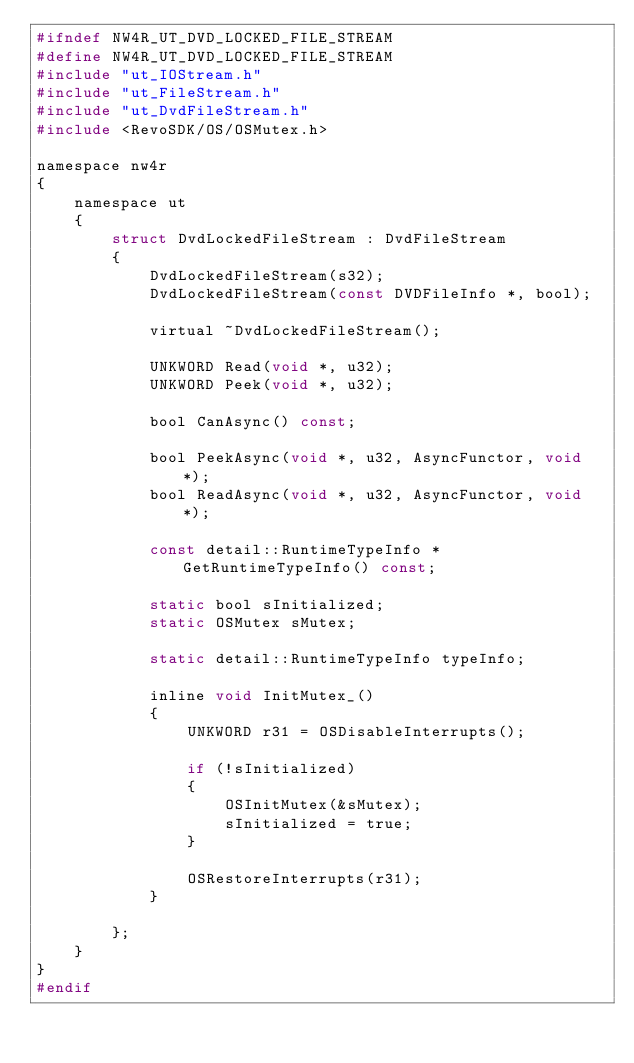<code> <loc_0><loc_0><loc_500><loc_500><_C_>#ifndef NW4R_UT_DVD_LOCKED_FILE_STREAM
#define NW4R_UT_DVD_LOCKED_FILE_STREAM
#include "ut_IOStream.h"
#include "ut_FileStream.h"
#include "ut_DvdFileStream.h"
#include <RevoSDK/OS/OSMutex.h>

namespace nw4r
{
	namespace ut
	{
		struct DvdLockedFileStream : DvdFileStream
		{
			DvdLockedFileStream(s32);
			DvdLockedFileStream(const DVDFileInfo *, bool);
			
			virtual ~DvdLockedFileStream();
			
			UNKWORD Read(void *, u32);
			UNKWORD Peek(void *, u32);
			
			bool CanAsync() const;

			bool PeekAsync(void *, u32, AsyncFunctor, void *);
			bool ReadAsync(void *, u32, AsyncFunctor, void *);
			
			const detail::RuntimeTypeInfo * GetRuntimeTypeInfo() const;
			
			static bool sInitialized;
			static OSMutex sMutex;
			
			static detail::RuntimeTypeInfo typeInfo;
			
			inline void InitMutex_()
			{
				UNKWORD r31 = OSDisableInterrupts();
				
				if (!sInitialized)
				{
					OSInitMutex(&sMutex);
					sInitialized = true;
				}
				
				OSRestoreInterrupts(r31);
			}
			
		};
	}
}
#endif</code> 